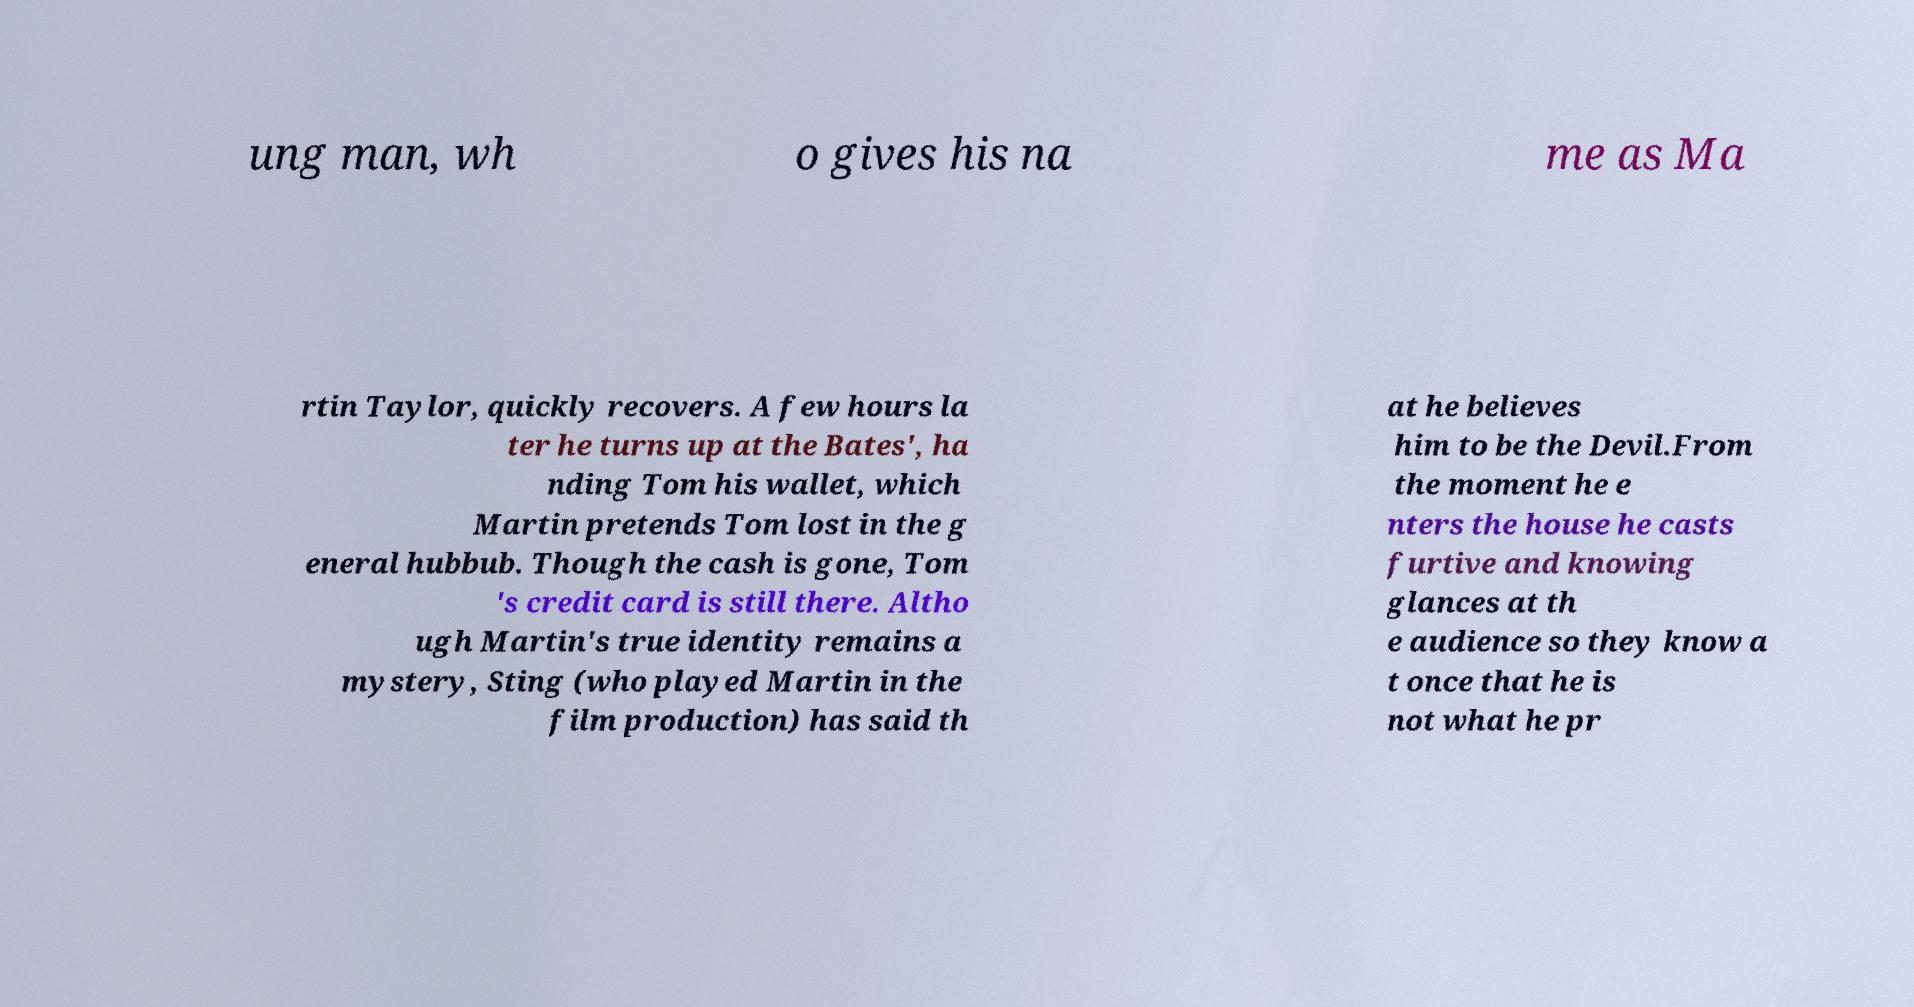Can you accurately transcribe the text from the provided image for me? ung man, wh o gives his na me as Ma rtin Taylor, quickly recovers. A few hours la ter he turns up at the Bates', ha nding Tom his wallet, which Martin pretends Tom lost in the g eneral hubbub. Though the cash is gone, Tom 's credit card is still there. Altho ugh Martin's true identity remains a mystery, Sting (who played Martin in the film production) has said th at he believes him to be the Devil.From the moment he e nters the house he casts furtive and knowing glances at th e audience so they know a t once that he is not what he pr 